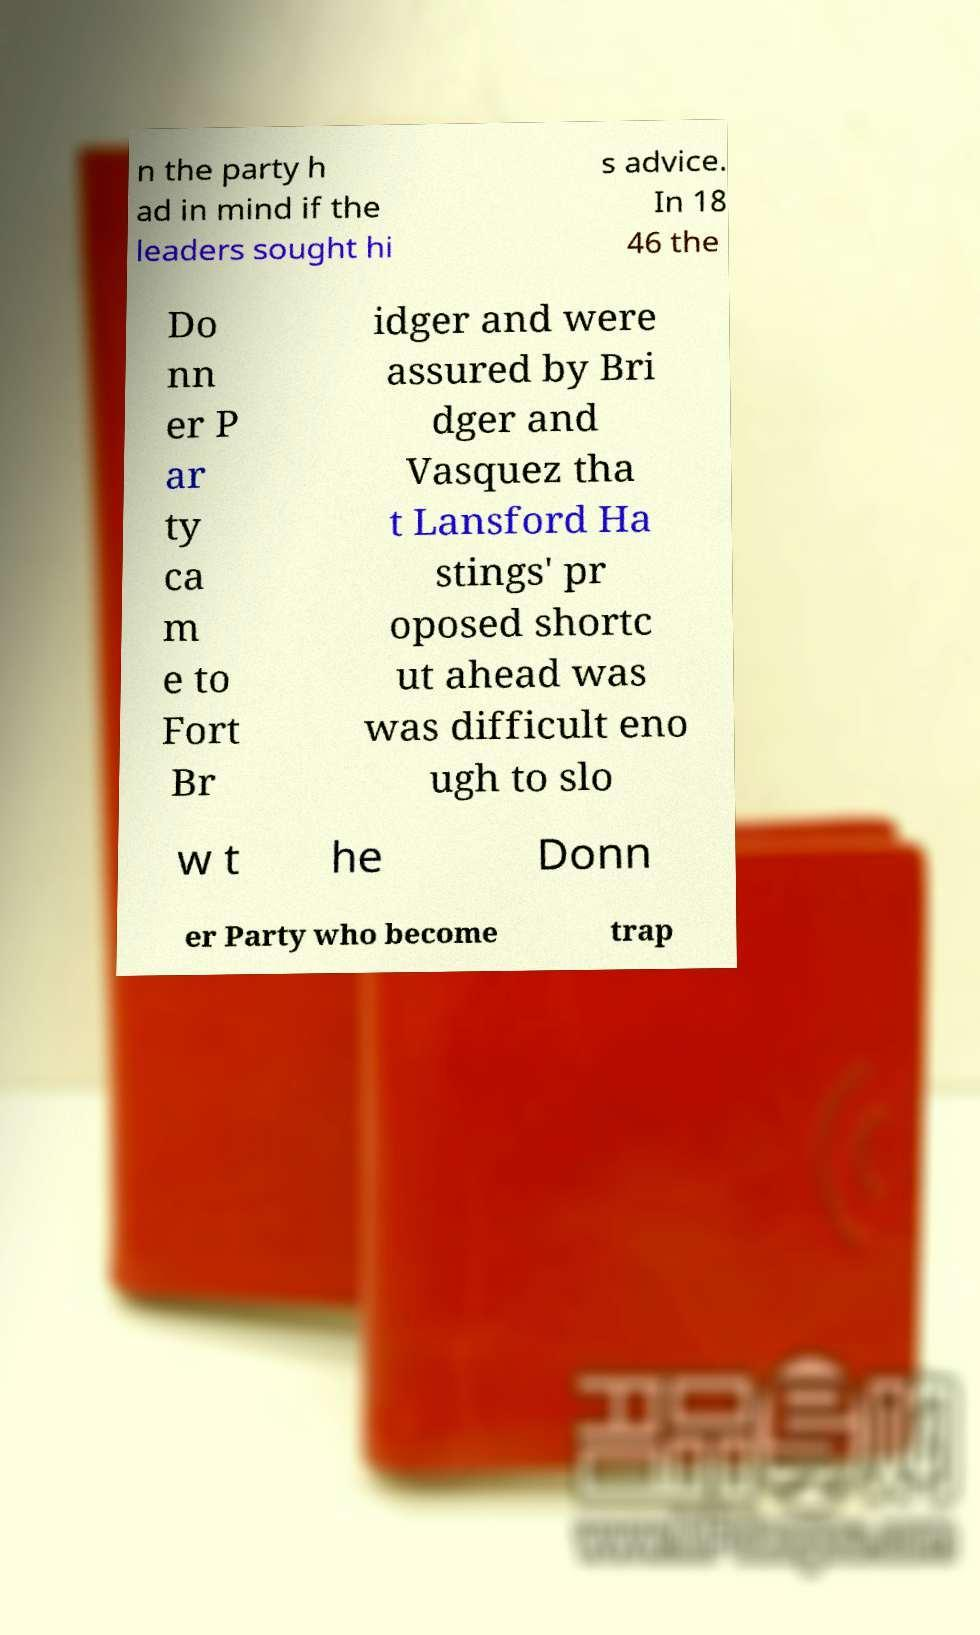What messages or text are displayed in this image? I need them in a readable, typed format. n the party h ad in mind if the leaders sought hi s advice. In 18 46 the Do nn er P ar ty ca m e to Fort Br idger and were assured by Bri dger and Vasquez tha t Lansford Ha stings' pr oposed shortc ut ahead was was difficult eno ugh to slo w t he Donn er Party who become trap 